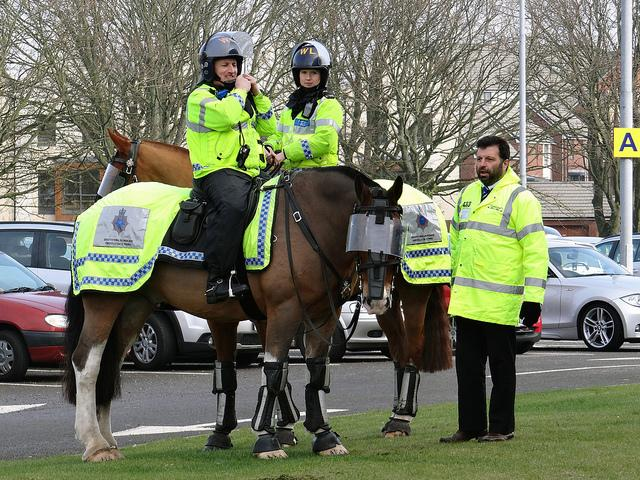What are they preparing for?

Choices:
A) parade
B) war
C) riot
D) fashion show riot 